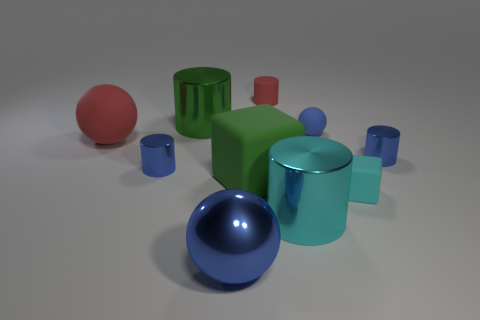There is another cube that is made of the same material as the tiny cyan block; what size is it?
Make the answer very short. Large. Are there fewer large green matte spheres than small blue balls?
Offer a terse response. Yes. How many big objects are either green rubber cylinders or matte balls?
Your response must be concise. 1. How many tiny objects are both behind the cyan rubber cube and in front of the green shiny cylinder?
Your answer should be very brief. 3. Are there more red matte cylinders than cyan objects?
Give a very brief answer. No. What number of other things are there of the same shape as the cyan matte object?
Provide a short and direct response. 1. Does the big block have the same color as the matte cylinder?
Make the answer very short. No. The tiny thing that is both to the right of the large cube and on the left side of the small rubber ball is made of what material?
Make the answer very short. Rubber. The green shiny cylinder has what size?
Ensure brevity in your answer.  Large. There is a cyan block right of the matte object on the left side of the blue metal sphere; what number of blue rubber things are in front of it?
Offer a very short reply. 0. 